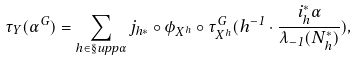<formula> <loc_0><loc_0><loc_500><loc_500>\tau _ { Y } ( \alpha ^ { G } ) = \sum _ { h \in \S u p p \alpha } j _ { h * } \circ \phi _ { X ^ { h } } \circ \tau ^ { G } _ { X ^ { h } } ( h ^ { - 1 } \cdot \frac { i _ { h } ^ { * } \alpha } { \lambda _ { - 1 } ( N ^ { * } _ { h } ) } ) ,</formula> 